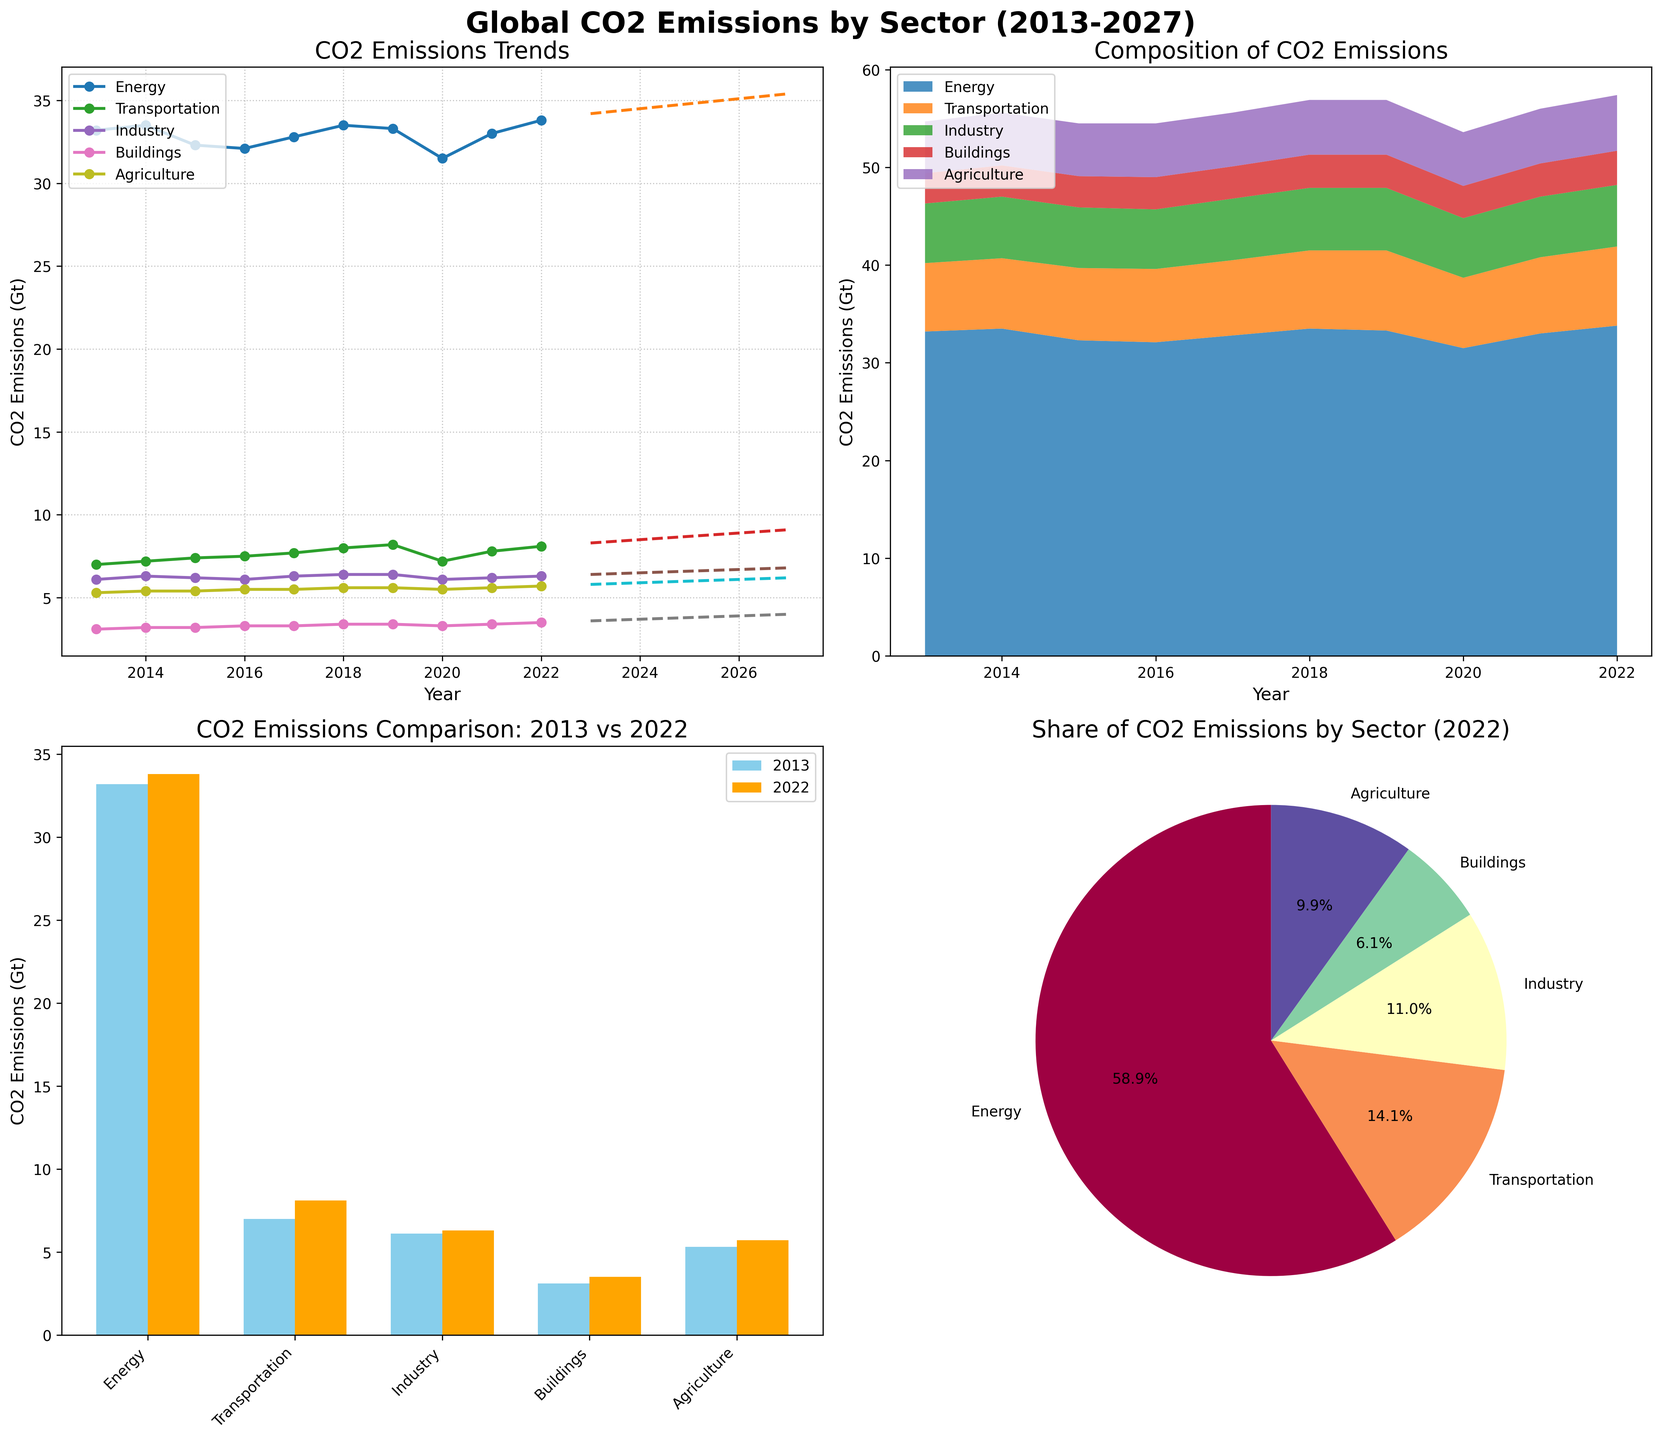Which year has the highest CO2 emissions in the Energy sector? The line plot for the Energy sector shows maximum CO2 emissions occurring in 2022 with 33.8 Gt.
Answer: 2022 What is the total CO2 emission from all sectors in 2015? Sum the CO2 emissions for all sectors in 2015: Energy (32.3) + Transportation (7.4) + Industry (6.2) + Buildings (3.2) + Agriculture (5.4) = 54.5 Gt.
Answer: 54.5 How do CO2 emissions in the Transportation sector in 2020 compare to 2022? In the bar plot, Transportation emissions in 2020 are 7.2 Gt and in 2022 are 8.1 Gt. Thus, emissions increased by 0.9 Gt.
Answer: increased by 0.9 Gt Which sector is projected to have the largest increase in CO2 emissions between 2023 and 2027? From the line plot’s projected data points, calculate the increase for each sector: 
Energy: 35.4 - 34.2 = 1.2 Gt
Transportation: 9.1 - 8.3 = 0.8 Gt
Industry: 6.8 - 6.4 = 0.4 Gt
Buildings: 4.0 - 3.6 = 0.4 Gt
Agriculture: 6.2 - 5.8 = 0.4 Gt
Hence, the largest increase is in the Energy sector with 1.2 Gt.
Answer: Energy What percentage of total CO2 emissions did the Transportation sector contribute in 2013? From the pie chart for 2022: 
Transportation emissions in 2013 are 7.0 Gt. 
Total emissions in 2013 are (Energy 33.2 + Transportation 7.0 + Industry 6.1 + Buildings 3.1 + Agriculture 5.3) = 54.7 Gt.
The percentage is (7.0 / 54.7) * 100 ≈ 12.8%.
Answer: 12.8% By how much did CO2 emissions in the Buildings sector change from 2013 to 2022? The bar plot shows Buildings' CO2 emissions in 2013 are 3.1 Gt and in 2022 are 3.5 Gt. The change is (3.5 - 3.1) = 0.4 Gt.
Answer: increased by 0.4 Gt In the stacked area plot, which sector had the smallest share of CO2 emissions in 2020? Observing the relative sizes in the stacked area plot, Buildings had the smallest share in 2020.
Answer: Buildings Which sector's CO2 emissions remained most stable from 2013 to 2022 in the line plot? By inspecting the line plot, Industry sector shows the least fluctuation with emissions staying around 6.1 to 6.4 Gt.
Answer: Industry What CO2 emission trend can be seen in the Energy sector projections from 2023 to 2027? The projections in the line plot for the Energy sector show a continuous increase from 34.2 Gt in 2023 to 35.4 Gt in 2027.
Answer: increasing trend 